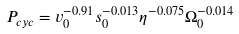Convert formula to latex. <formula><loc_0><loc_0><loc_500><loc_500>P _ { c y c } = v _ { 0 } ^ { - 0 . 9 1 } s _ { 0 } ^ { - 0 . 0 1 3 } \eta ^ { - 0 . 0 7 5 } \Omega _ { 0 } ^ { - 0 . 0 1 4 }</formula> 